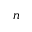Convert formula to latex. <formula><loc_0><loc_0><loc_500><loc_500>n</formula> 